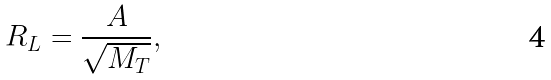Convert formula to latex. <formula><loc_0><loc_0><loc_500><loc_500>R _ { L } = \frac { A } { \sqrt { M _ { T } } } ,</formula> 